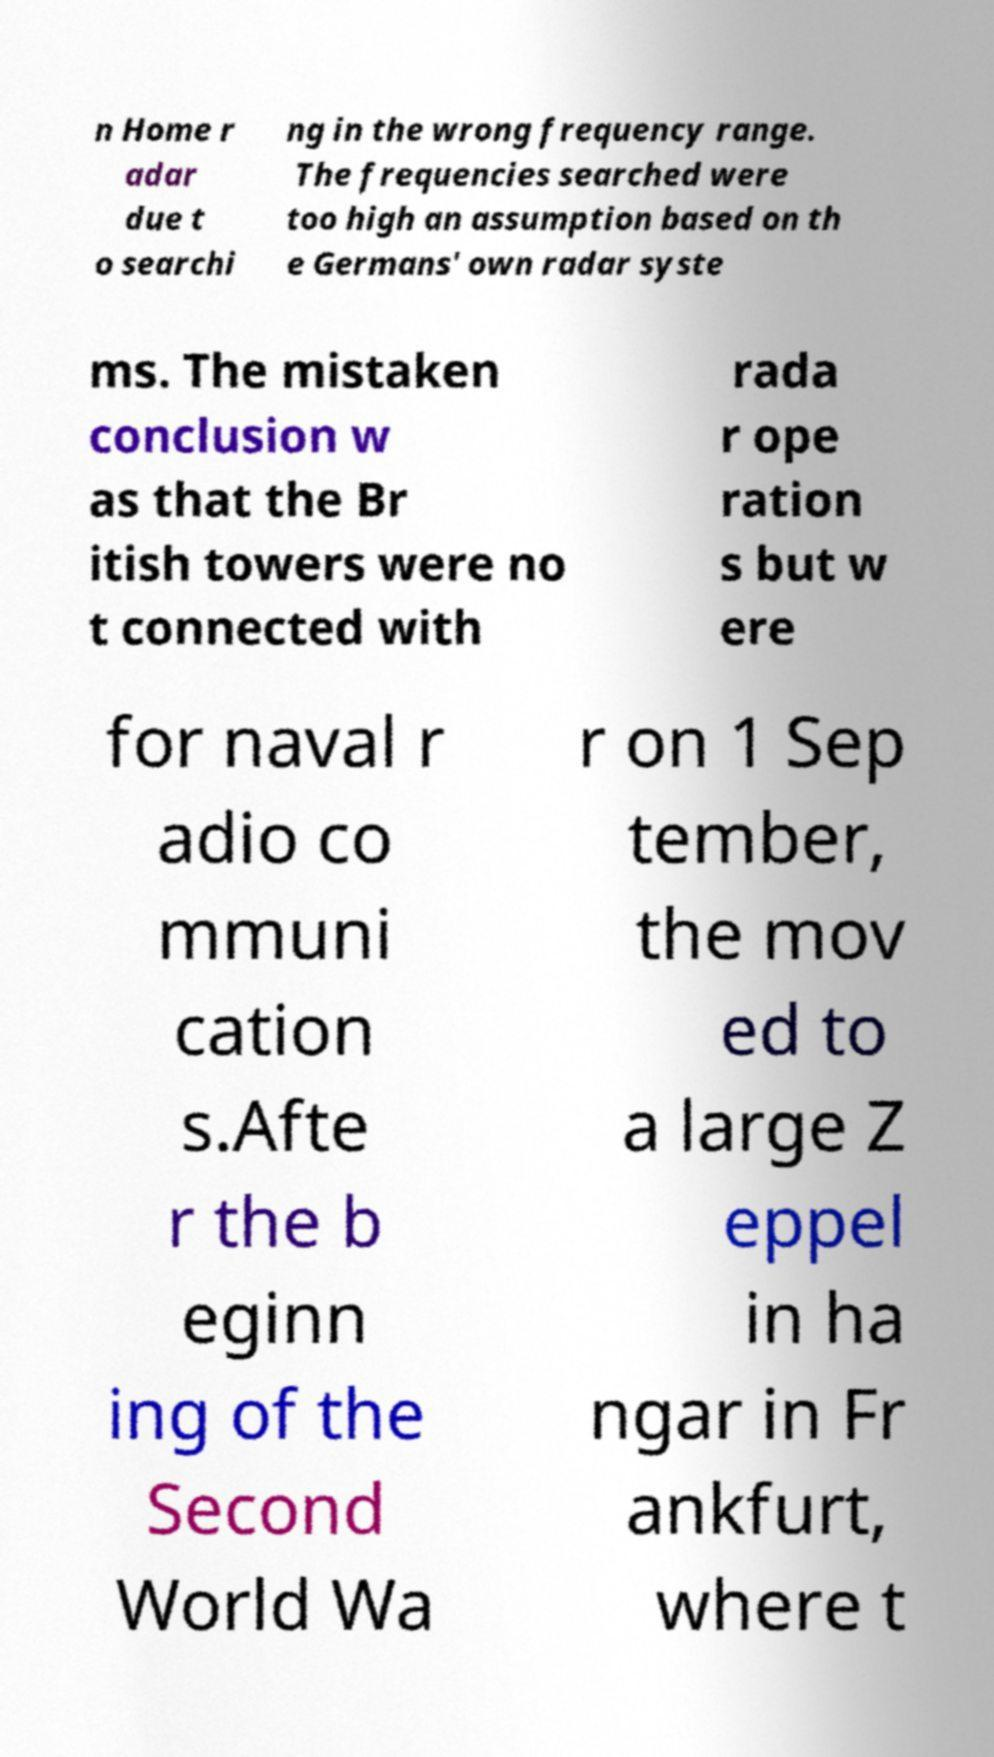What messages or text are displayed in this image? I need them in a readable, typed format. n Home r adar due t o searchi ng in the wrong frequency range. The frequencies searched were too high an assumption based on th e Germans' own radar syste ms. The mistaken conclusion w as that the Br itish towers were no t connected with rada r ope ration s but w ere for naval r adio co mmuni cation s.Afte r the b eginn ing of the Second World Wa r on 1 Sep tember, the mov ed to a large Z eppel in ha ngar in Fr ankfurt, where t 